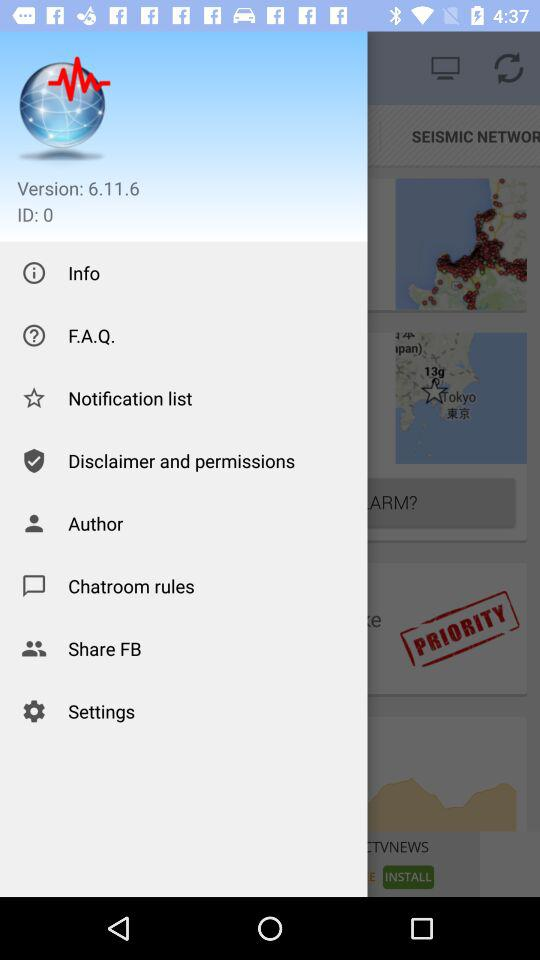What is the version? The version is 6.11.6. 